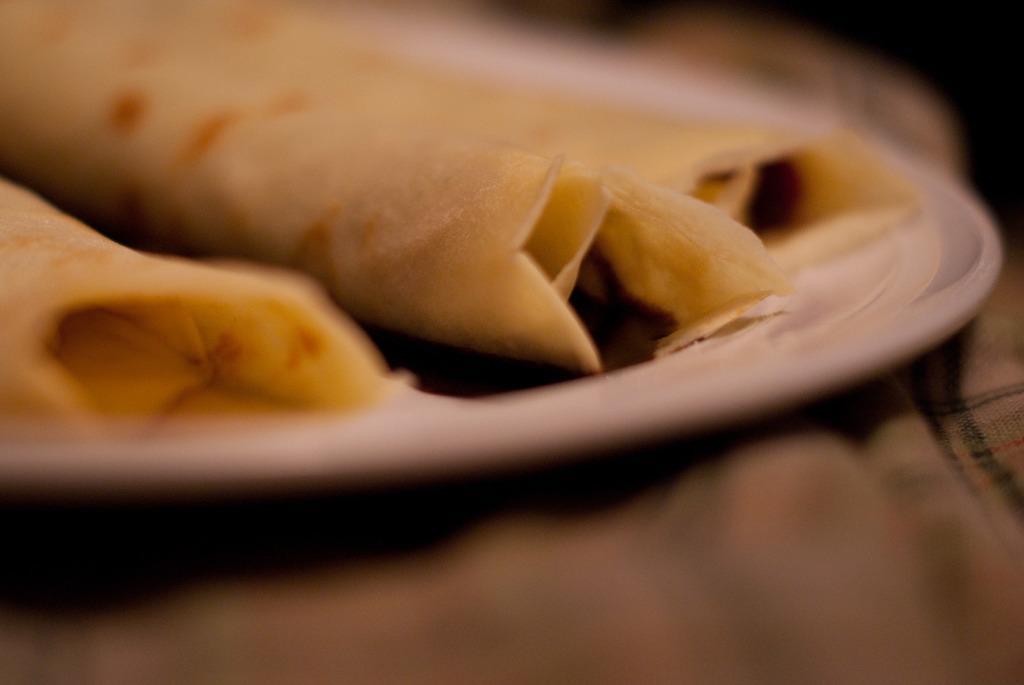Please provide a concise description of this image. In this image, we can see food on the white plate. At the top and bottom of the image, we can see blur view. Here there is a cloth. 